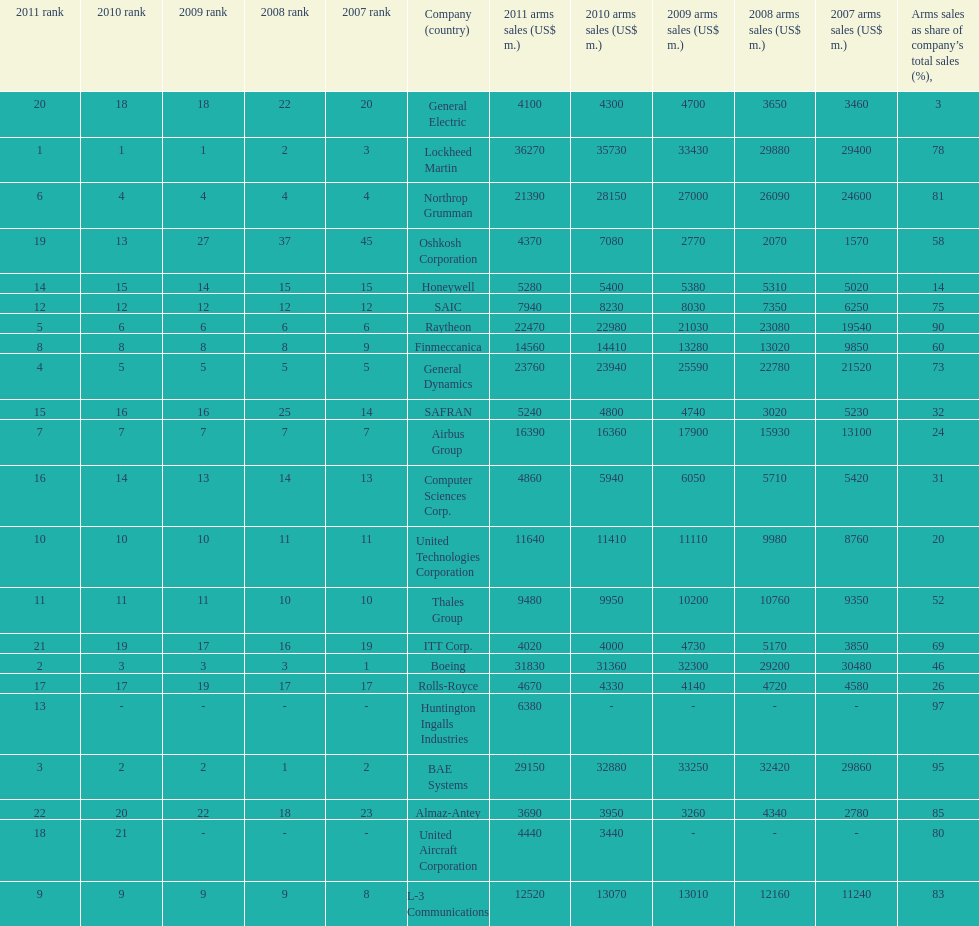How many different countries are listed? 6. 